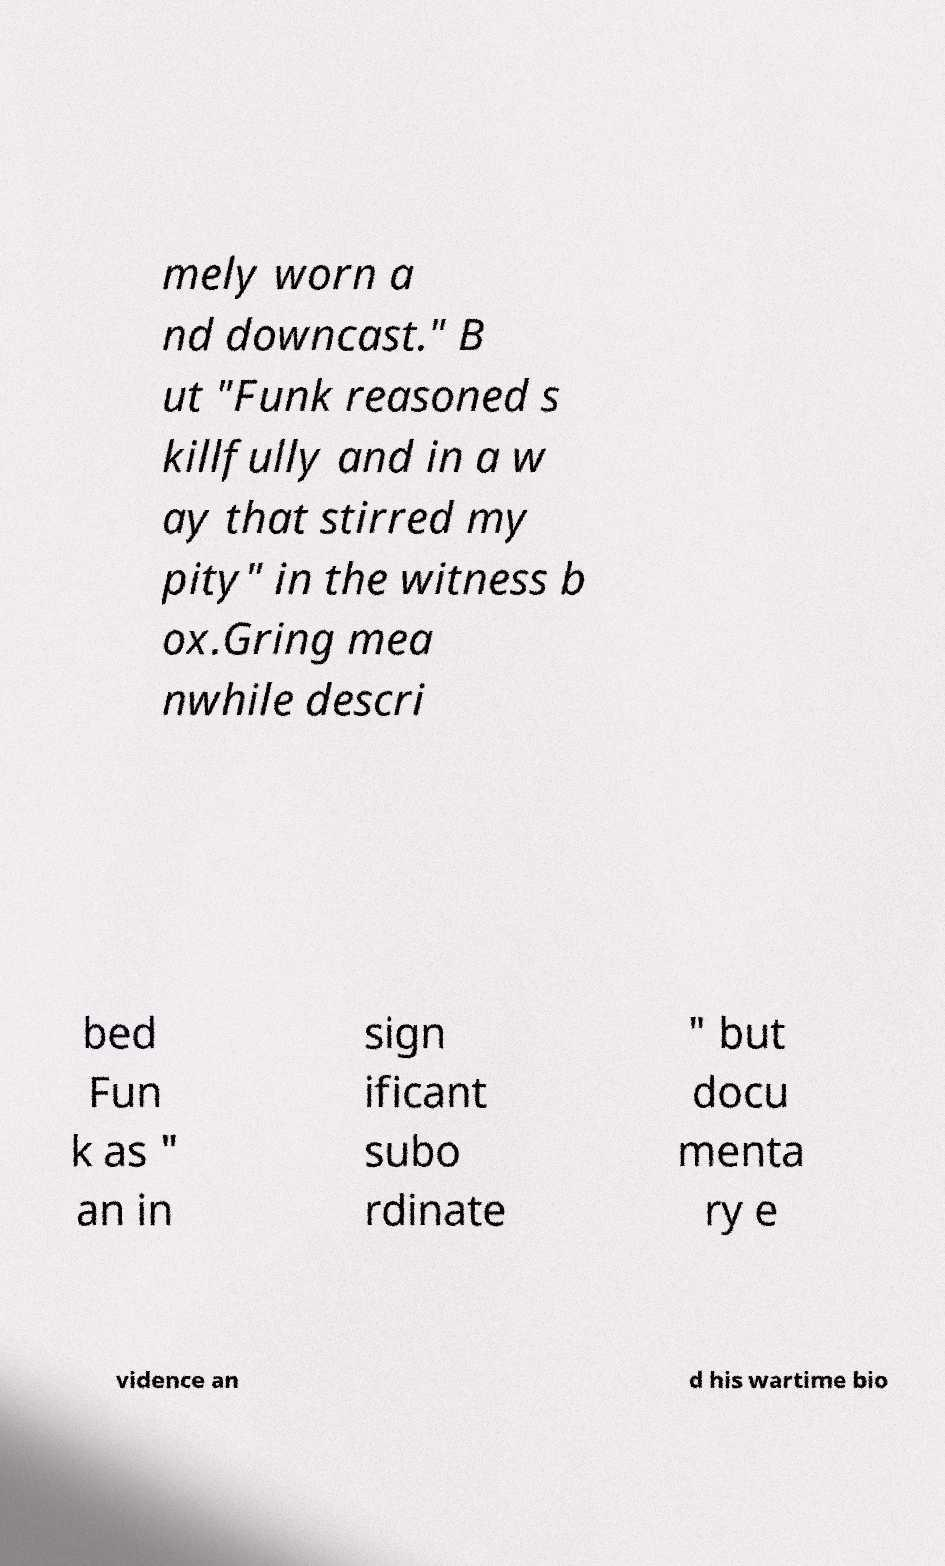There's text embedded in this image that I need extracted. Can you transcribe it verbatim? mely worn a nd downcast." B ut "Funk reasoned s killfully and in a w ay that stirred my pity" in the witness b ox.Gring mea nwhile descri bed Fun k as " an in sign ificant subo rdinate " but docu menta ry e vidence an d his wartime bio 